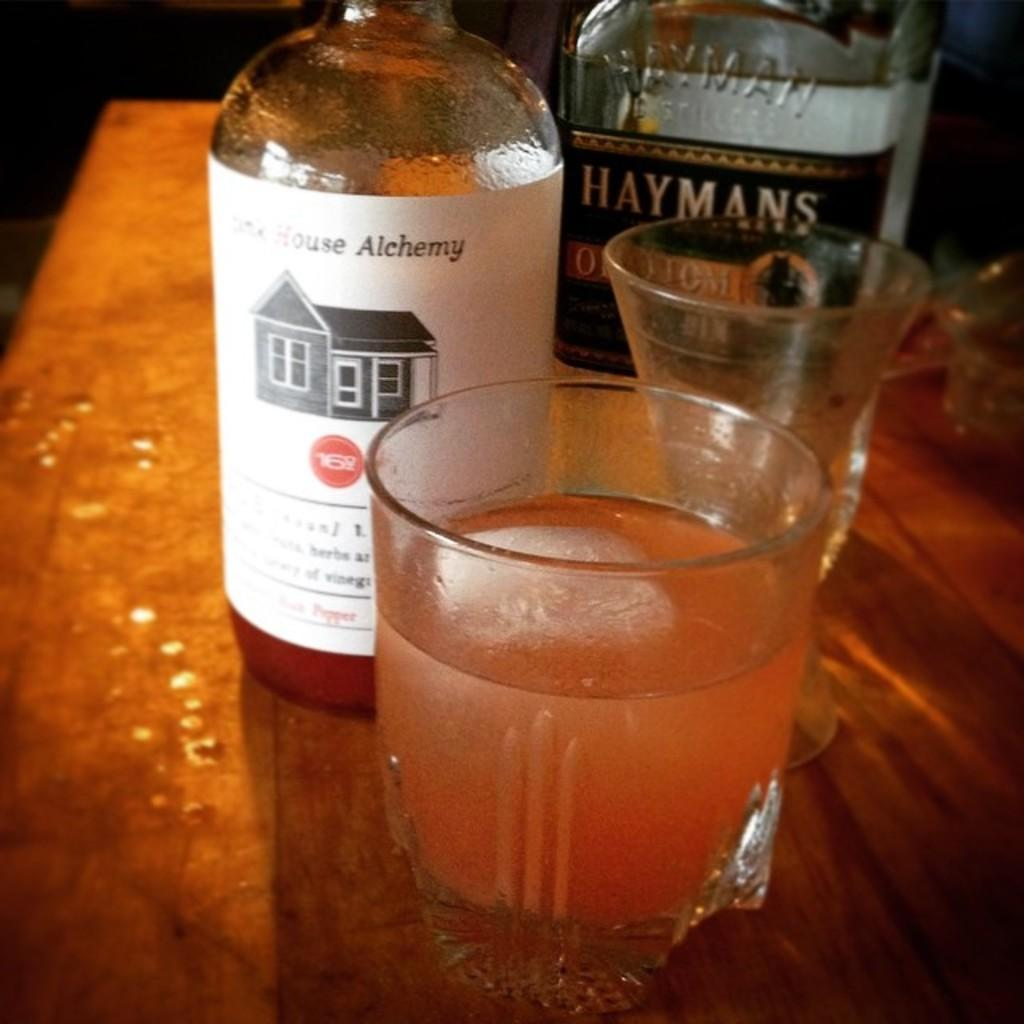How many glasses can be seen in the image? There are two glasses in the image. What else is present on the table in the image? There are bottles on the table in the image. Can you describe the background of the image? The background of the image is dark. What type of van can be seen driving along the river in the image? There is no van or river present in the image; it only features two glasses and bottles on a table with a dark background. 